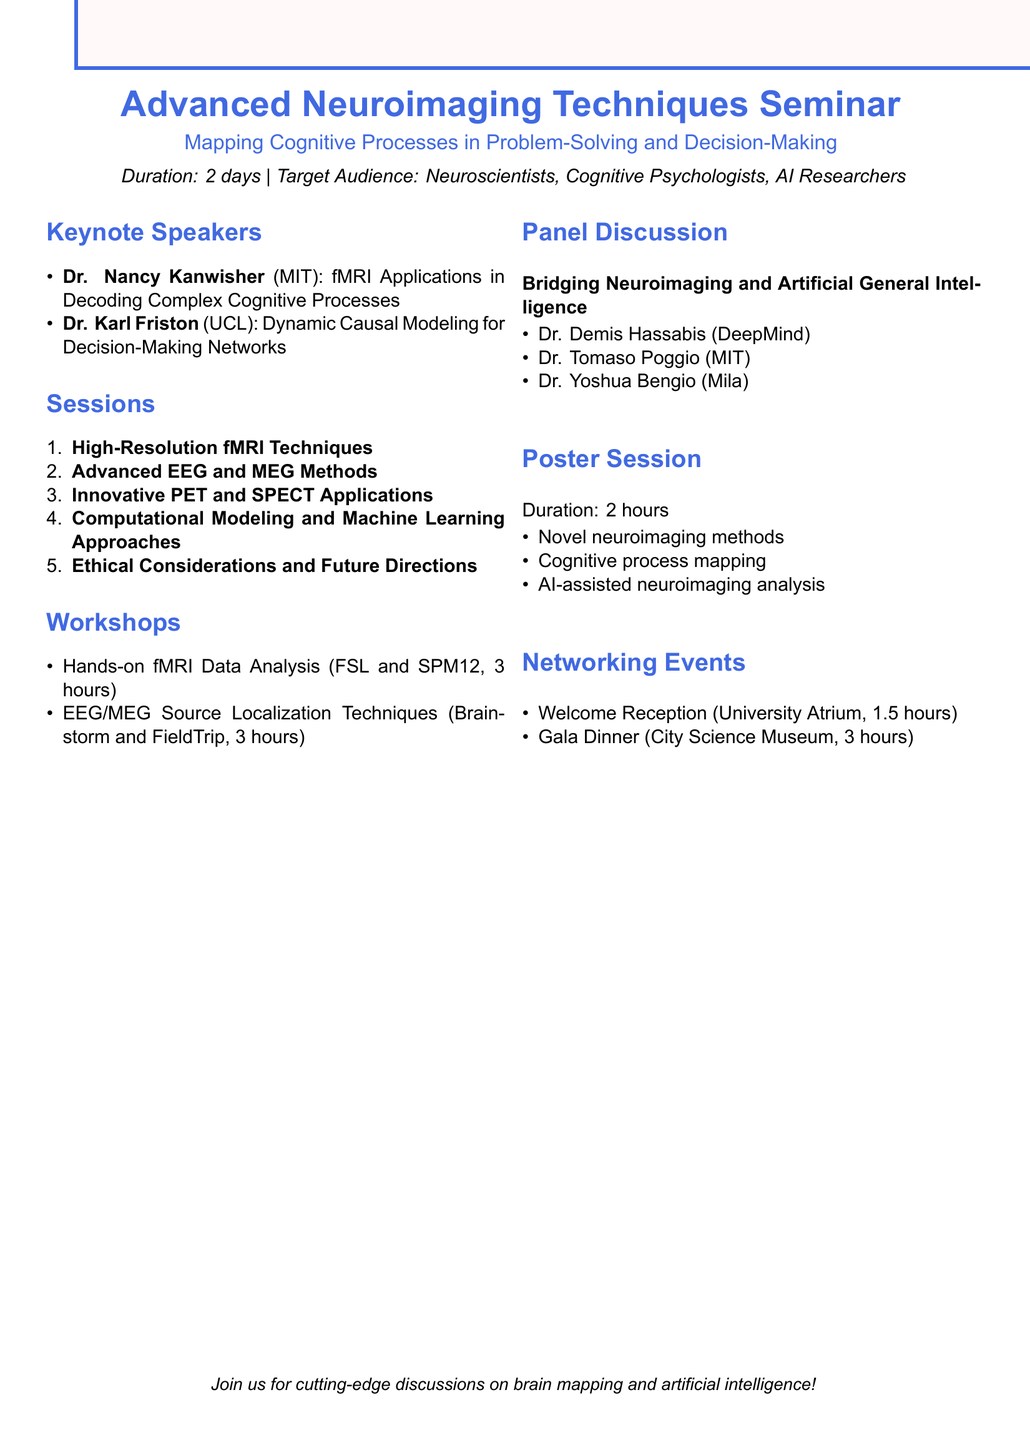What is the title of the seminar? The title of the seminar is explicitly stated at the beginning of the document as "Advanced Neuroimaging Techniques for Mapping Cognitive Processes in Problem-Solving and Decision-Making."
Answer: Advanced Neuroimaging Techniques for Mapping Cognitive Processes in Problem-Solving and Decision-Making How many days will the seminar last? The document states that the seminar will last for "2 days."
Answer: 2 days Who is a keynote speaker from MIT? The document lists Dr. Nancy Kanwisher from MIT as a keynote speaker.
Answer: Dr. Nancy Kanwisher What techniques are covered under High-Resolution fMRI Techniques? The subtopics listed for this session include "7T fMRI for fine-grained neural activity mapping," "Multi-voxel pattern analysis (MVPA)," and "Real-time fMRI neurofeedback."
Answer: 7T fMRI for fine-grained neural activity mapping, Multi-voxel pattern analysis (MVPA), Real-time fMRI neurofeedback What is the duration of the Hands-on fMRI Data Analysis workshop? The Hands-on fMRI Data Analysis workshop is specified to last for "3 hours."
Answer: 3 hours Who are the panelists in the panel discussion? The panelists listed in the document are Dr. Demis Hassabis, Dr. Tomaso Poggio, and Dr. Yoshua Bengio.
Answer: Dr. Demis Hassabis, Dr. Tomaso Poggio, Dr. Yoshua Bengio What is one of the categories for the poster session? The document provides categories such as "Novel neuroimaging methods," "Cognitive process mapping," and "AI-assisted neuroimaging analysis."
Answer: Novel neuroimaging methods What is the venue for the Welcome Reception? The document mentions that the venue for the Welcome Reception is "University Atrium."
Answer: University Atrium 